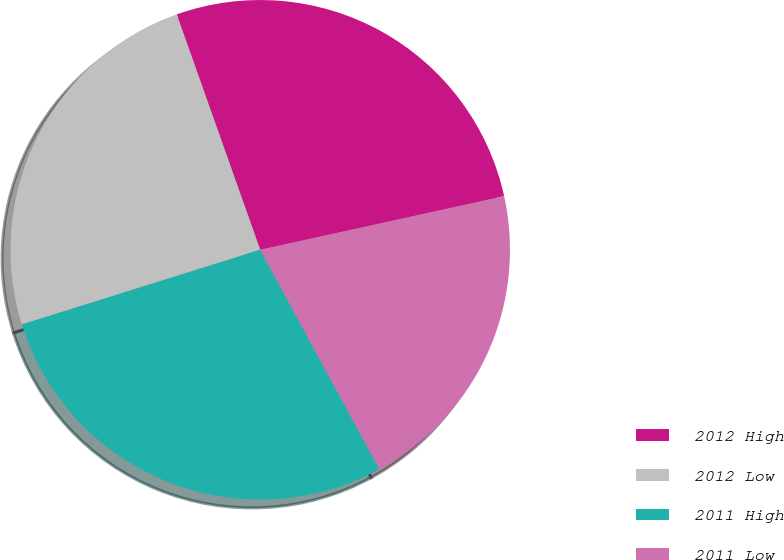<chart> <loc_0><loc_0><loc_500><loc_500><pie_chart><fcel>2012 High<fcel>2012 Low<fcel>2011 High<fcel>2011 Low<nl><fcel>26.98%<fcel>24.41%<fcel>28.09%<fcel>20.52%<nl></chart> 